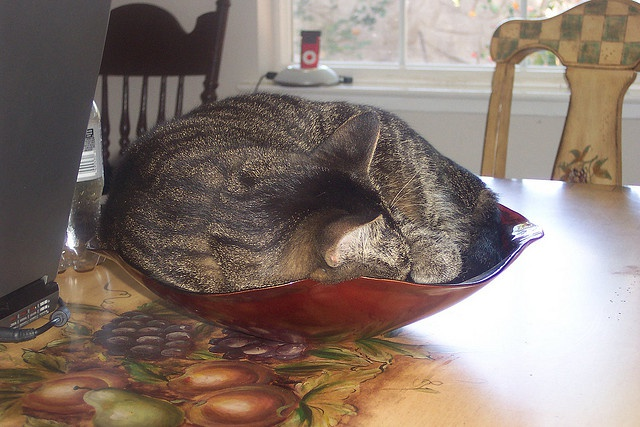Describe the objects in this image and their specific colors. I can see dining table in gray, white, and maroon tones, cat in gray and black tones, laptop in gray and black tones, chair in gray, tan, and brown tones, and bowl in gray, maroon, black, and brown tones in this image. 